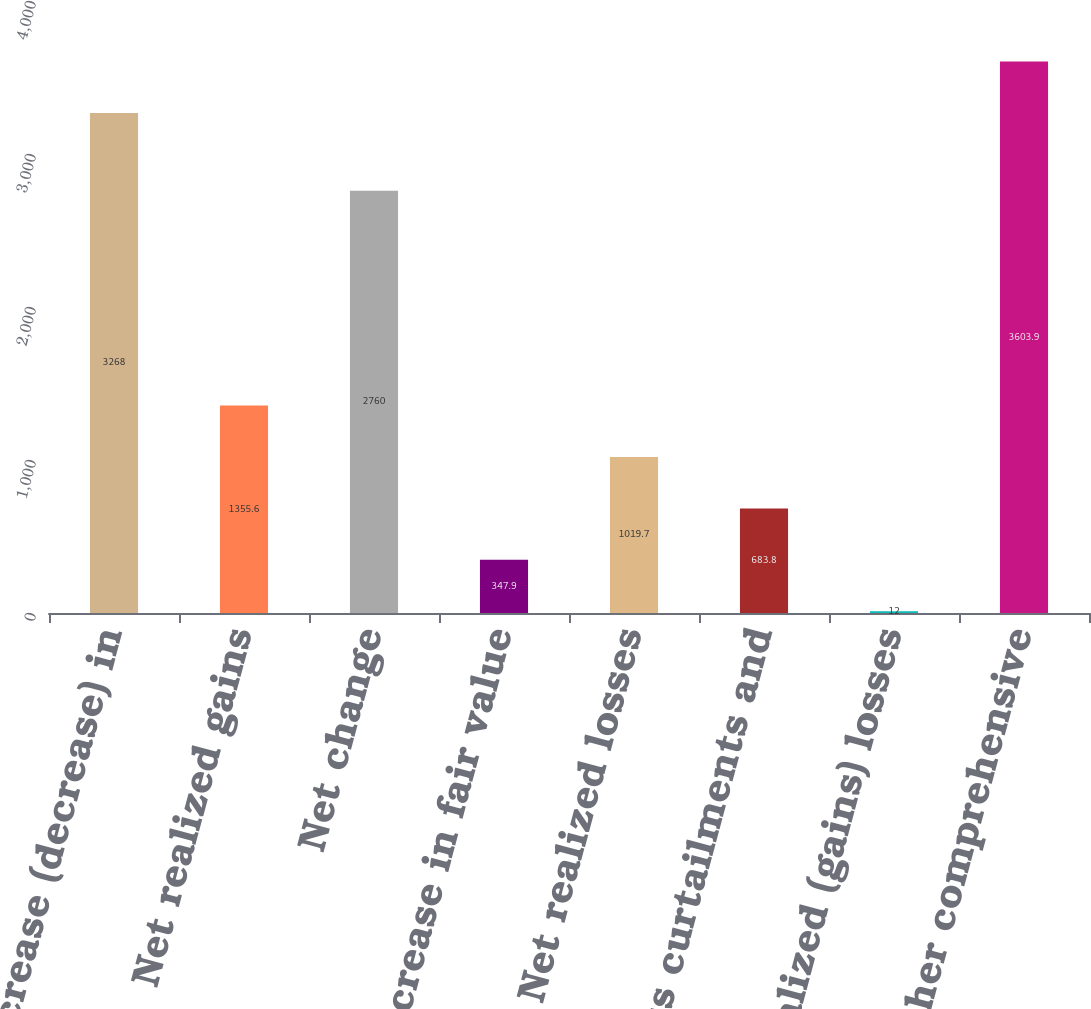<chart> <loc_0><loc_0><loc_500><loc_500><bar_chart><fcel>Net increase (decrease) in<fcel>Net realized gains<fcel>Net change<fcel>Net increase in fair value<fcel>Net realized losses<fcel>Settlements curtailments and<fcel>Net realized (gains) losses<fcel>Total other comprehensive<nl><fcel>3268<fcel>1355.6<fcel>2760<fcel>347.9<fcel>1019.7<fcel>683.8<fcel>12<fcel>3603.9<nl></chart> 